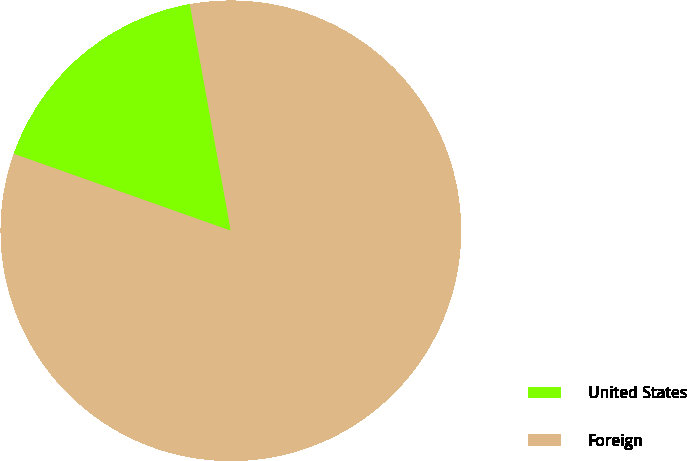Convert chart to OTSL. <chart><loc_0><loc_0><loc_500><loc_500><pie_chart><fcel>United States<fcel>Foreign<nl><fcel>16.73%<fcel>83.27%<nl></chart> 